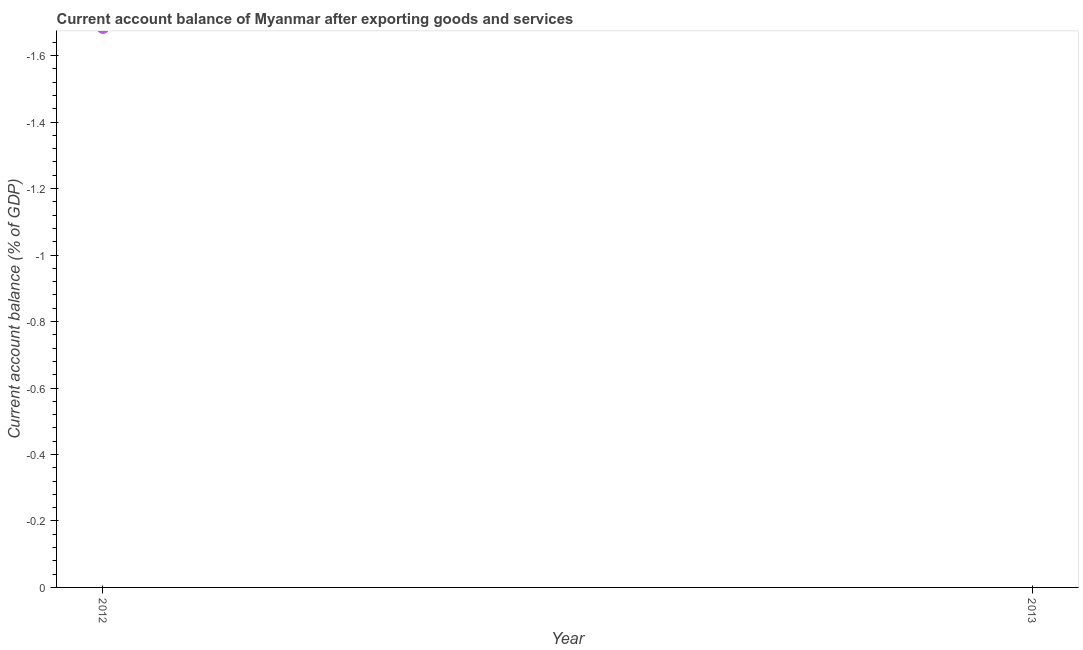Across all years, what is the minimum current account balance?
Ensure brevity in your answer.  0. What is the sum of the current account balance?
Provide a succinct answer. 0. What is the average current account balance per year?
Make the answer very short. 0. Does the current account balance monotonically increase over the years?
Provide a succinct answer. No. How many years are there in the graph?
Make the answer very short. 2. What is the difference between two consecutive major ticks on the Y-axis?
Offer a terse response. 0.2. Does the graph contain grids?
Provide a succinct answer. No. What is the title of the graph?
Provide a short and direct response. Current account balance of Myanmar after exporting goods and services. What is the label or title of the Y-axis?
Give a very brief answer. Current account balance (% of GDP). 